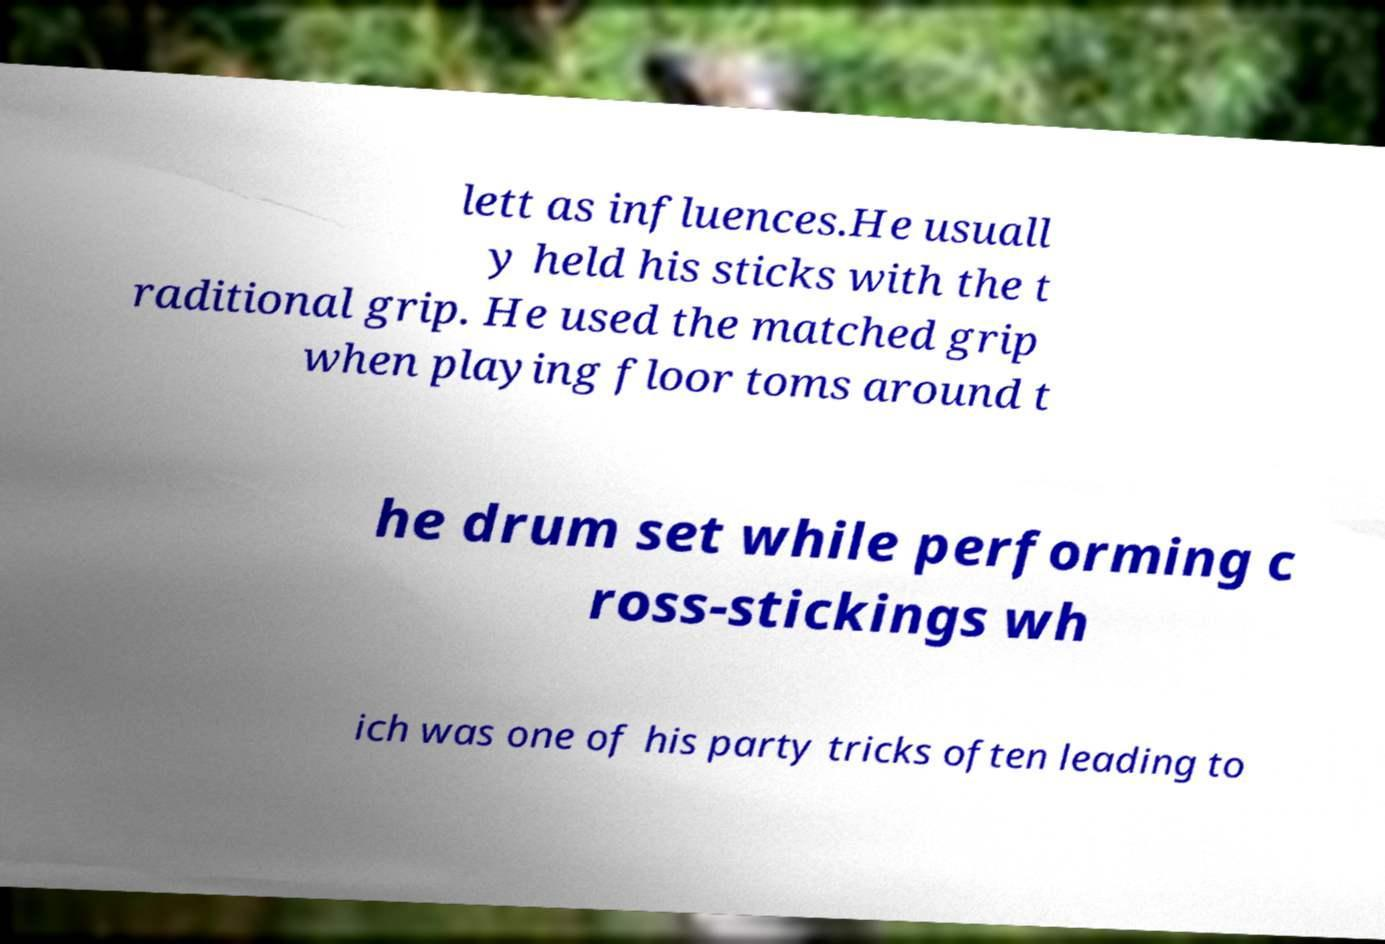For documentation purposes, I need the text within this image transcribed. Could you provide that? lett as influences.He usuall y held his sticks with the t raditional grip. He used the matched grip when playing floor toms around t he drum set while performing c ross-stickings wh ich was one of his party tricks often leading to 